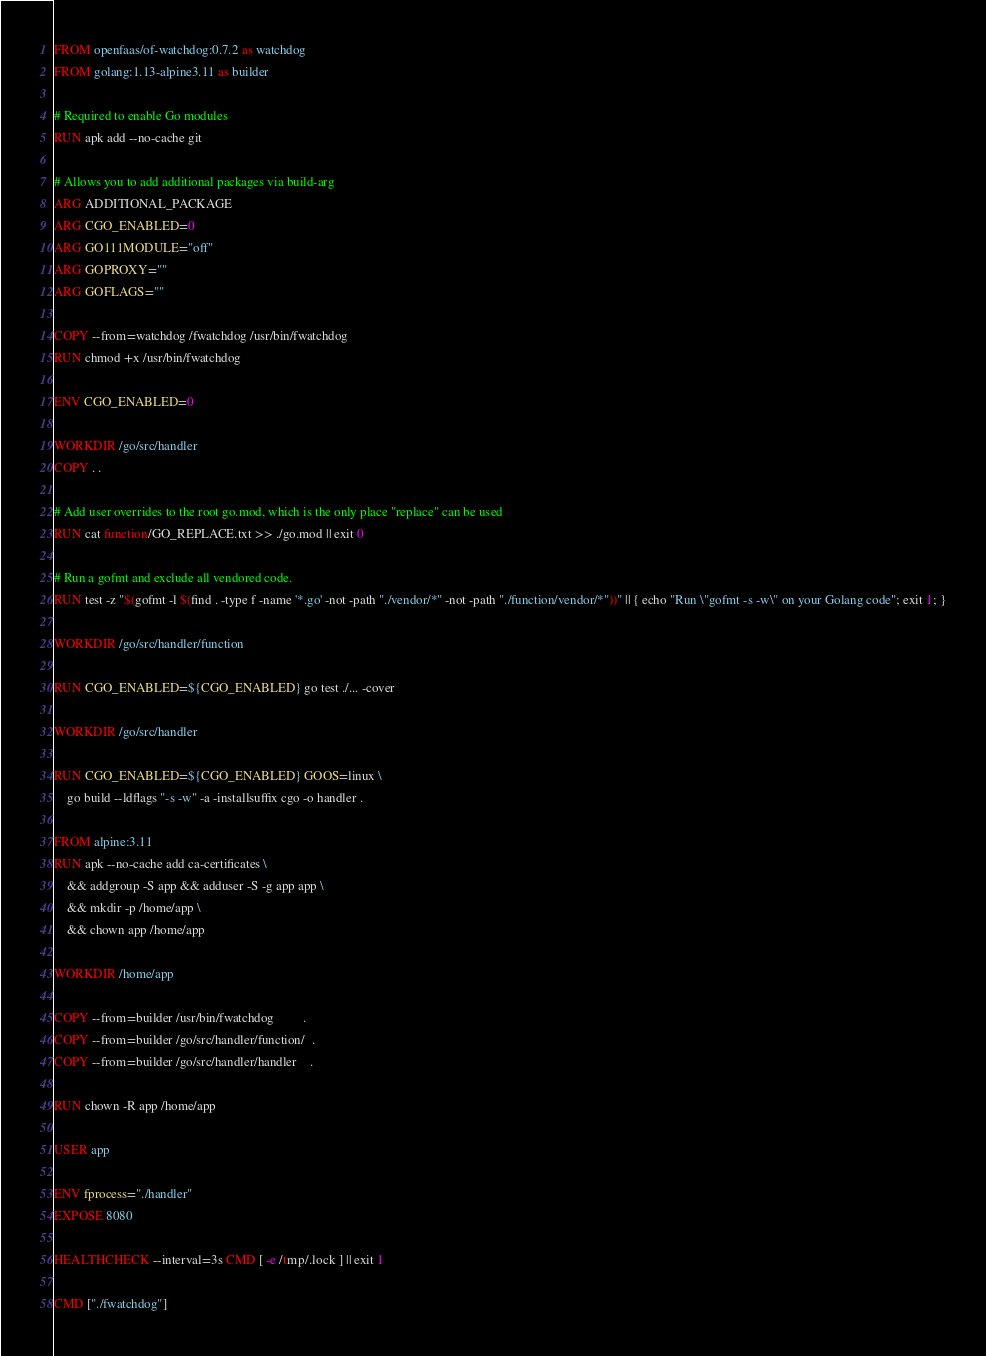Convert code to text. <code><loc_0><loc_0><loc_500><loc_500><_Dockerfile_>FROM openfaas/of-watchdog:0.7.2 as watchdog
FROM golang:1.13-alpine3.11 as builder

# Required to enable Go modules
RUN apk add --no-cache git

# Allows you to add additional packages via build-arg
ARG ADDITIONAL_PACKAGE
ARG CGO_ENABLED=0
ARG GO111MODULE="off"
ARG GOPROXY=""
ARG GOFLAGS=""

COPY --from=watchdog /fwatchdog /usr/bin/fwatchdog
RUN chmod +x /usr/bin/fwatchdog

ENV CGO_ENABLED=0

WORKDIR /go/src/handler
COPY . .

# Add user overrides to the root go.mod, which is the only place "replace" can be used
RUN cat function/GO_REPLACE.txt >> ./go.mod || exit 0

# Run a gofmt and exclude all vendored code.
RUN test -z "$(gofmt -l $(find . -type f -name '*.go' -not -path "./vendor/*" -not -path "./function/vendor/*"))" || { echo "Run \"gofmt -s -w\" on your Golang code"; exit 1; }

WORKDIR /go/src/handler/function

RUN CGO_ENABLED=${CGO_ENABLED} go test ./... -cover

WORKDIR /go/src/handler

RUN CGO_ENABLED=${CGO_ENABLED} GOOS=linux \
    go build --ldflags "-s -w" -a -installsuffix cgo -o handler .

FROM alpine:3.11
RUN apk --no-cache add ca-certificates \
    && addgroup -S app && adduser -S -g app app \
    && mkdir -p /home/app \
    && chown app /home/app

WORKDIR /home/app

COPY --from=builder /usr/bin/fwatchdog         .
COPY --from=builder /go/src/handler/function/  .
COPY --from=builder /go/src/handler/handler    .

RUN chown -R app /home/app

USER app

ENV fprocess="./handler"
EXPOSE 8080

HEALTHCHECK --interval=3s CMD [ -e /tmp/.lock ] || exit 1

CMD ["./fwatchdog"]
</code> 